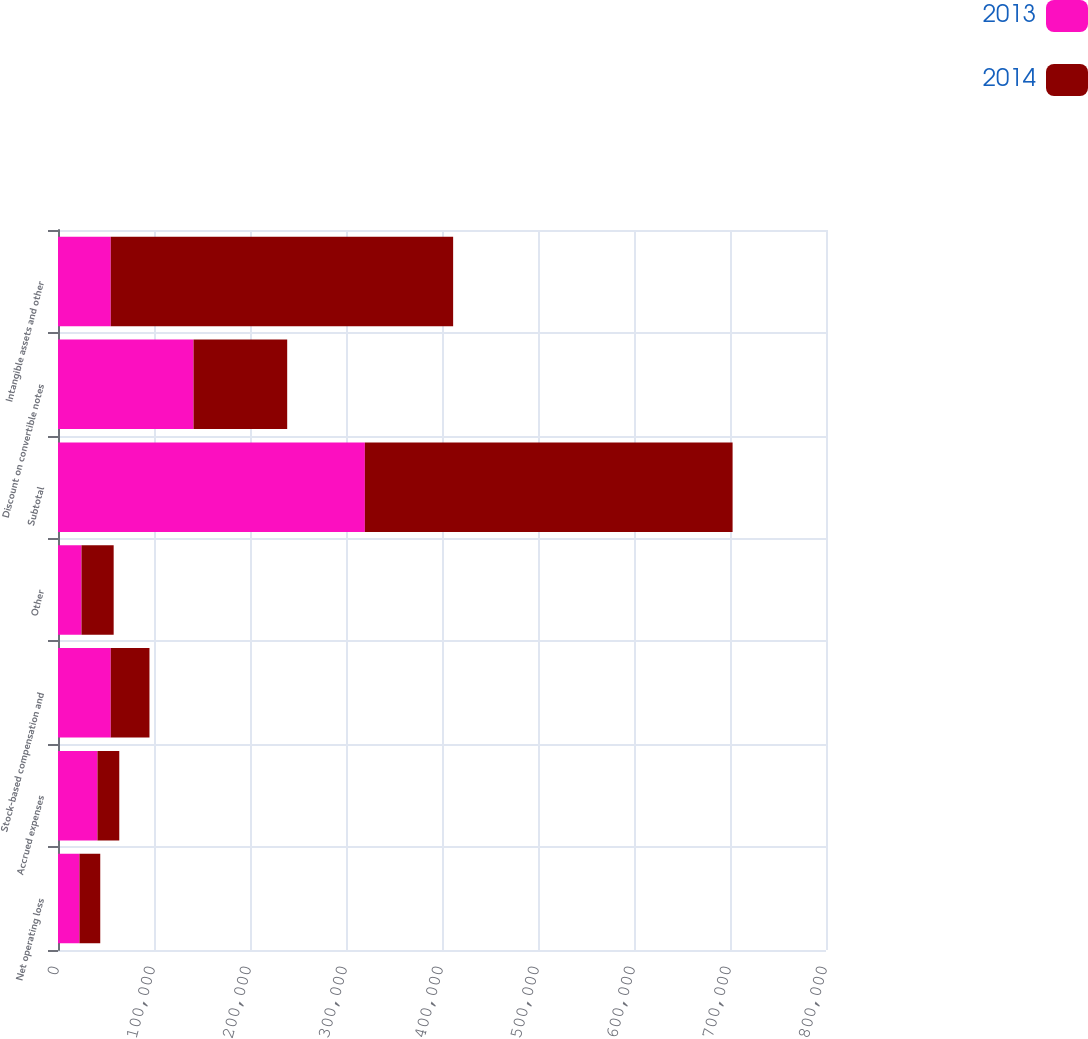Convert chart to OTSL. <chart><loc_0><loc_0><loc_500><loc_500><stacked_bar_chart><ecel><fcel>Net operating loss<fcel>Accrued expenses<fcel>Stock-based compensation and<fcel>Other<fcel>Subtotal<fcel>Discount on convertible notes<fcel>Intangible assets and other<nl><fcel>2013<fcel>22353<fcel>41117<fcel>54935<fcel>24456<fcel>319647<fcel>141193<fcel>54935<nl><fcel>2014<fcel>21660<fcel>22708<fcel>40346<fcel>33530<fcel>383056<fcel>97550<fcel>356669<nl></chart> 